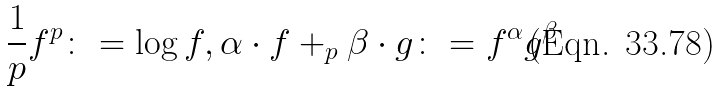Convert formula to latex. <formula><loc_0><loc_0><loc_500><loc_500>\frac { 1 } { p } f ^ { p } \colon = \log f , \alpha \cdot f + _ { p } \beta \cdot g \colon = f ^ { \alpha } g ^ { \beta } \,</formula> 